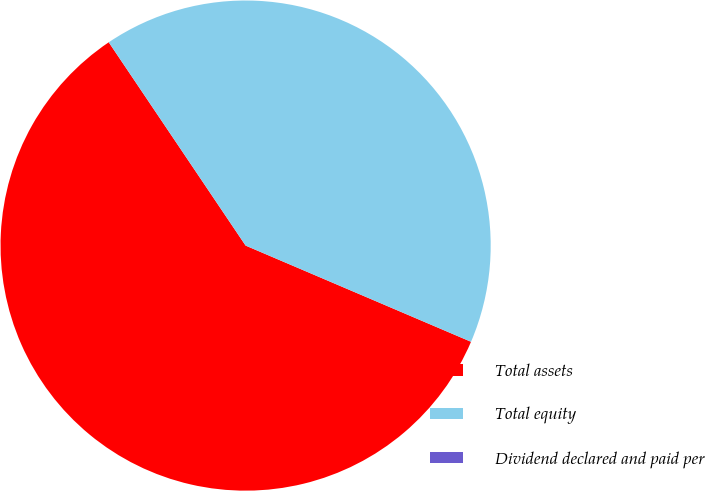<chart> <loc_0><loc_0><loc_500><loc_500><pie_chart><fcel>Total assets<fcel>Total equity<fcel>Dividend declared and paid per<nl><fcel>59.15%<fcel>40.85%<fcel>0.0%<nl></chart> 